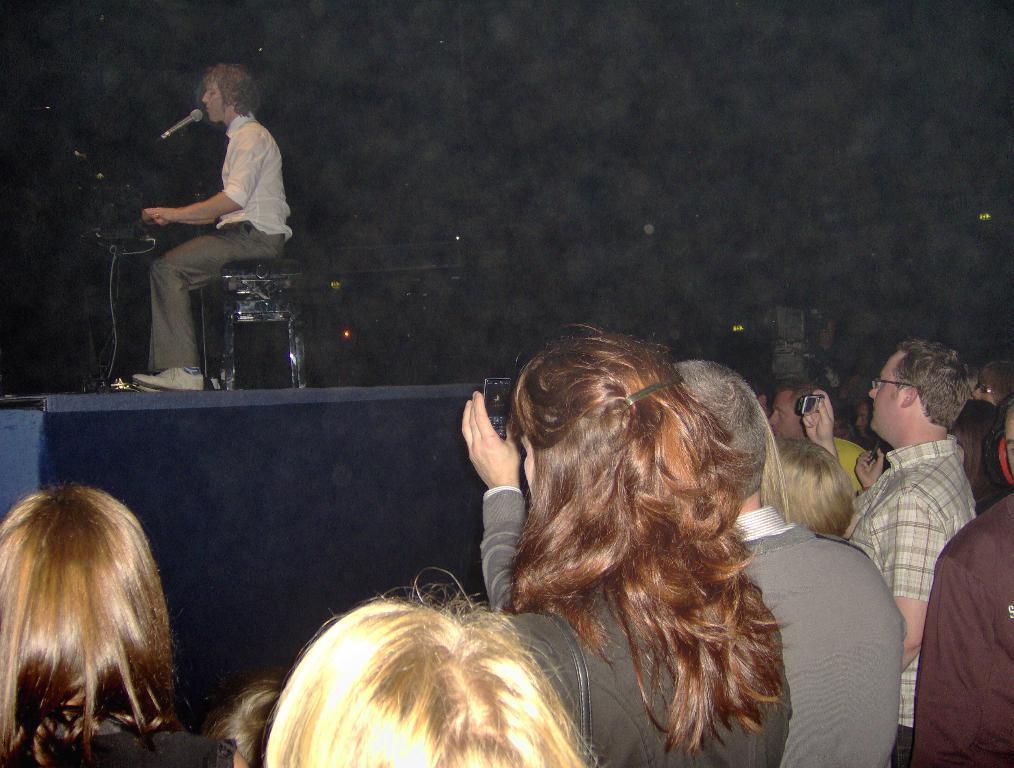Could you give a brief overview of what you see in this image? In the image in the center, we can see one stage. On the stage, we can see one person sitting and holding some object. In front of him, there is a microphone. In the bottom of the image, we can see a few people are standing and holding a mobile phone. 